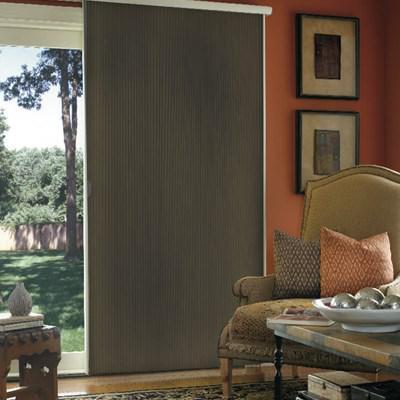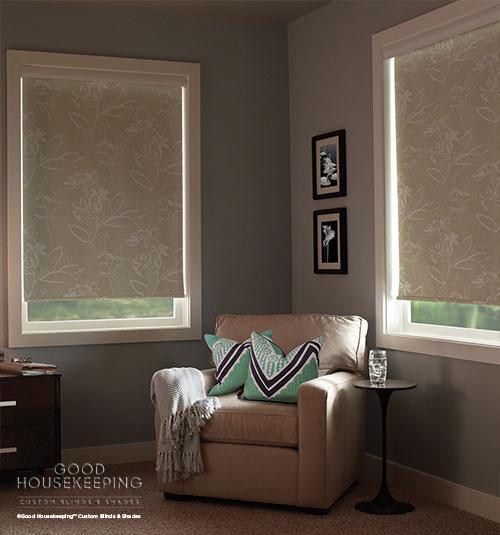The first image is the image on the left, the second image is the image on the right. Considering the images on both sides, is "In at least one image there is a pant on a side table in front of blinds." valid? Answer yes or no. No. 